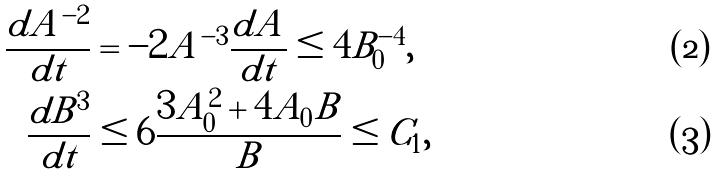<formula> <loc_0><loc_0><loc_500><loc_500>\frac { d A ^ { - 2 } } { d t } & = - 2 A ^ { - 3 } \frac { d A } { d t } \leq 4 B _ { 0 } ^ { - 4 } , \\ \frac { d B ^ { 3 } } { d t } & \leq 6 \frac { 3 A _ { 0 } ^ { 2 } + 4 A _ { 0 } B } { B } \leq C _ { 1 } ,</formula> 